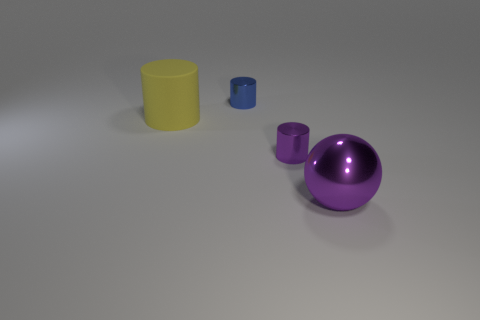There is a metal object that is on the left side of the large purple shiny object and on the right side of the blue object; what shape is it?
Offer a terse response. Cylinder. What is the size of the purple sphere in front of the blue metal thing?
Provide a short and direct response. Large. There is a small cylinder in front of the small object that is behind the yellow rubber cylinder; what number of purple metal things are on the right side of it?
Offer a very short reply. 1. Are there any blue cylinders in front of the tiny purple shiny cylinder?
Your response must be concise. No. What number of other things are there of the same size as the metal ball?
Give a very brief answer. 1. What is the thing that is on the left side of the big metallic sphere and in front of the yellow rubber cylinder made of?
Ensure brevity in your answer.  Metal. There is a metallic thing to the left of the tiny purple object; is its shape the same as the small shiny thing in front of the big yellow cylinder?
Ensure brevity in your answer.  Yes. Is there anything else that is made of the same material as the yellow object?
Make the answer very short. No. There is a small object behind the large thing that is left of the tiny object to the right of the blue cylinder; what is its shape?
Your answer should be compact. Cylinder. What number of other objects are the same shape as the big purple shiny thing?
Your answer should be very brief. 0. 